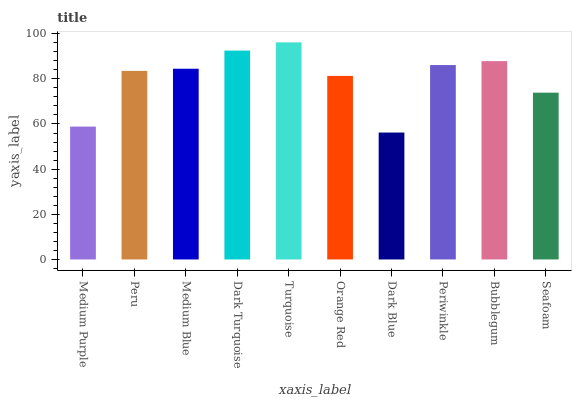Is Dark Blue the minimum?
Answer yes or no. Yes. Is Turquoise the maximum?
Answer yes or no. Yes. Is Peru the minimum?
Answer yes or no. No. Is Peru the maximum?
Answer yes or no. No. Is Peru greater than Medium Purple?
Answer yes or no. Yes. Is Medium Purple less than Peru?
Answer yes or no. Yes. Is Medium Purple greater than Peru?
Answer yes or no. No. Is Peru less than Medium Purple?
Answer yes or no. No. Is Medium Blue the high median?
Answer yes or no. Yes. Is Peru the low median?
Answer yes or no. Yes. Is Turquoise the high median?
Answer yes or no. No. Is Dark Blue the low median?
Answer yes or no. No. 